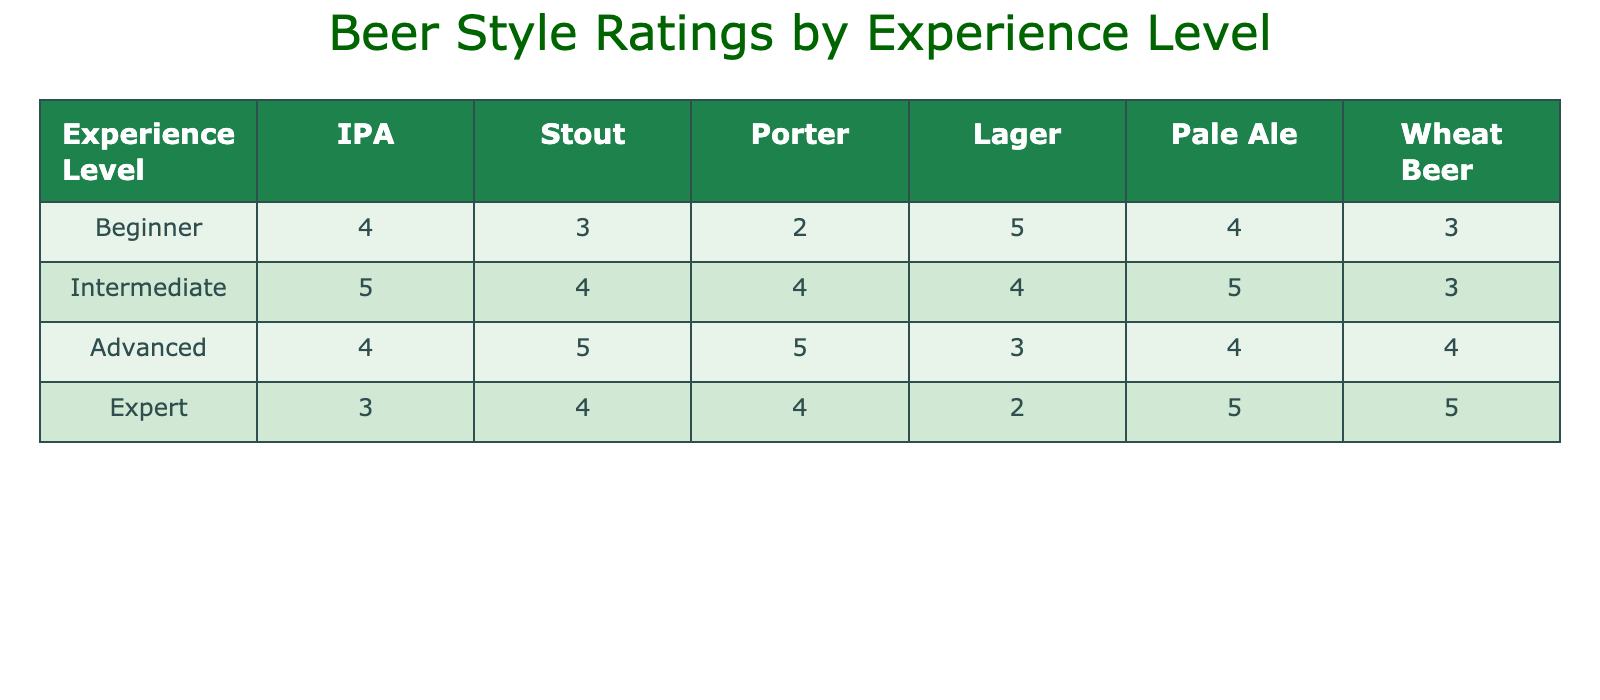What is the rating of IPA from beginners? From the table, the value under the "Beginner" row for IPA is 4.
Answer: 4 Which beer style received the highest rating from advanced drinkers? In the advanced row, the ratings for beer styles are: IPA (4), Stout (5), Porter (5), Lager (3), Pale Ale (4), and Wheat Beer (4). The highest ratings are for Stout and Porter, both with a score of 5.
Answer: Stout and Porter What is the average rating for Lager across all experience levels? The ratings for Lager from each experience level are: Beginner (5), Intermediate (4), Advanced (3), and Expert (2). To find the average, sum these ratings: 5 + 4 + 3 + 2 = 14 and divide by 4, giving 14/4 = 3.5.
Answer: 3.5 Did experts rate Lager higher than beginners? From the table, experts rated Lager at 2 and beginners rated it at 5. Since 2 is less than 5, the statement is false.
Answer: No Which beer style had the lowest rating from intermediate drinkers? For intermediate drinkers, the ratings for each style are: IPA (5), Stout (4), Porter (4), Lager (4), Pale Ale (5), and Wheat Beer (3). The lowest rating is for Wheat Beer at 3.
Answer: Wheat Beer What is the total rating of all beer styles from advanced drinkers? The advanced drinker's ratings are: IPA (4), Stout (5), Porter (5), Lager (3), Pale Ale (4), and Wheat Beer (4). Summing these gives: 4 + 5 + 5 + 3 + 4 + 4 = 25.
Answer: 25 Is there any beer style that received a perfect score of 5 for every experience level? By examining the ratings for each beer style across all experience levels, no style consistently received a perfect score of 5.
Answer: No Which experience level gave the highest rating for Pale Ale? The ratings for Pale Ale by experience level are: Beginner (4), Intermediate (5), Advanced (4), Expert (5). Both Intermediate and Expert gave the highest rating of 5.
Answer: Intermediate and Expert 